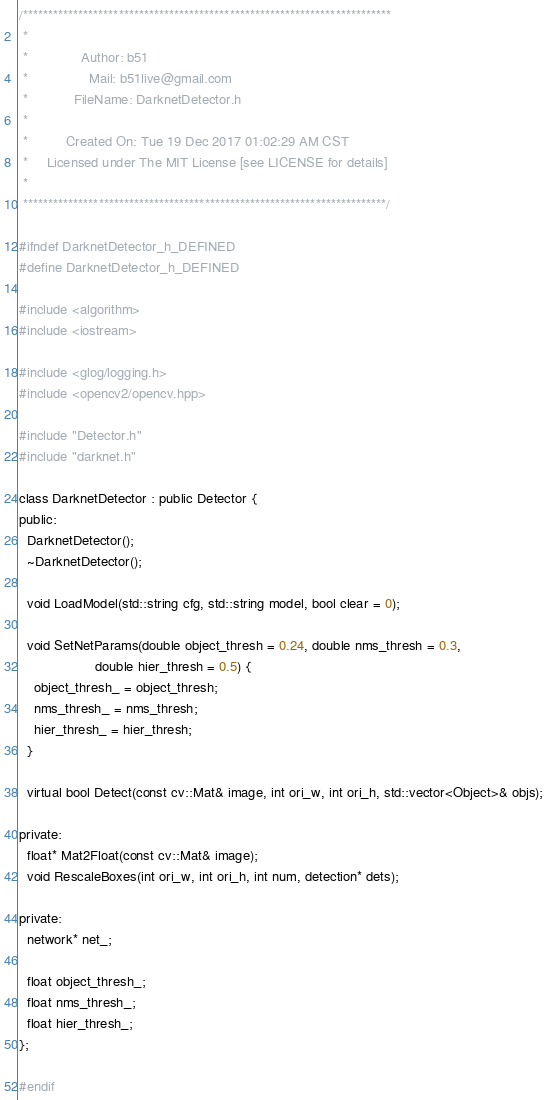Convert code to text. <code><loc_0><loc_0><loc_500><loc_500><_C_>/*************************************************************************
 *
 *              Author: b51
 *                Mail: b51live@gmail.com
 *            FileName: DarknetDetector.h
 *
 *          Created On: Tue 19 Dec 2017 01:02:29 AM CST
 *     Licensed under The MIT License [see LICENSE for details]
 *
 ************************************************************************/

#ifndef DarknetDetector_h_DEFINED
#define DarknetDetector_h_DEFINED

#include <algorithm>
#include <iostream>

#include <glog/logging.h>
#include <opencv2/opencv.hpp>

#include "Detector.h"
#include "darknet.h"

class DarknetDetector : public Detector {
public:
  DarknetDetector();
  ~DarknetDetector();

  void LoadModel(std::string cfg, std::string model, bool clear = 0);

  void SetNetParams(double object_thresh = 0.24, double nms_thresh = 0.3,
                    double hier_thresh = 0.5) {
    object_thresh_ = object_thresh;
    nms_thresh_ = nms_thresh;
    hier_thresh_ = hier_thresh;
  }

  virtual bool Detect(const cv::Mat& image, int ori_w, int ori_h, std::vector<Object>& objs);

private:
  float* Mat2Float(const cv::Mat& image);
  void RescaleBoxes(int ori_w, int ori_h, int num, detection* dets);

private:
  network* net_;

  float object_thresh_;
  float nms_thresh_;
  float hier_thresh_;
};

#endif
</code> 